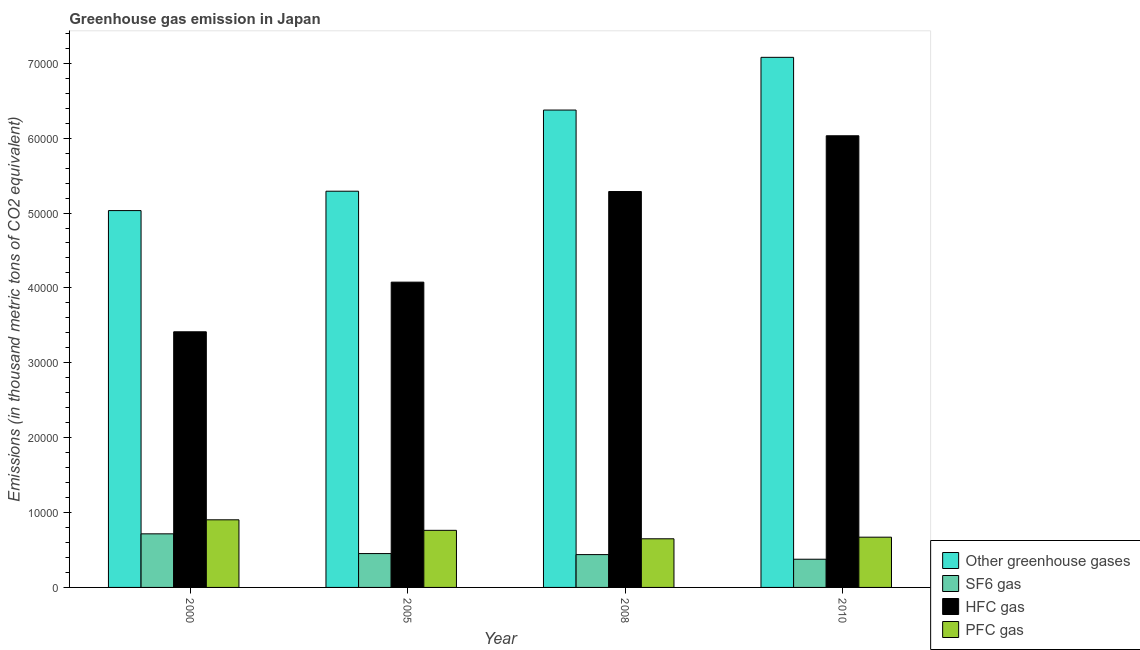Are the number of bars per tick equal to the number of legend labels?
Offer a very short reply. Yes. How many bars are there on the 3rd tick from the right?
Your response must be concise. 4. What is the label of the 4th group of bars from the left?
Ensure brevity in your answer.  2010. What is the emission of hfc gas in 2008?
Give a very brief answer. 5.29e+04. Across all years, what is the maximum emission of greenhouse gases?
Offer a terse response. 7.08e+04. Across all years, what is the minimum emission of pfc gas?
Your answer should be very brief. 6496.1. In which year was the emission of greenhouse gases minimum?
Make the answer very short. 2000. What is the total emission of greenhouse gases in the graph?
Make the answer very short. 2.38e+05. What is the difference between the emission of pfc gas in 2005 and that in 2010?
Offer a terse response. 913.6. What is the difference between the emission of greenhouse gases in 2008 and the emission of hfc gas in 2000?
Provide a short and direct response. 1.34e+04. What is the average emission of greenhouse gases per year?
Give a very brief answer. 5.94e+04. In the year 2010, what is the difference between the emission of sf6 gas and emission of hfc gas?
Offer a very short reply. 0. What is the ratio of the emission of hfc gas in 2000 to that in 2008?
Your answer should be very brief. 0.65. What is the difference between the highest and the second highest emission of hfc gas?
Your answer should be very brief. 7446.1. What is the difference between the highest and the lowest emission of hfc gas?
Ensure brevity in your answer.  2.62e+04. Is it the case that in every year, the sum of the emission of sf6 gas and emission of pfc gas is greater than the sum of emission of greenhouse gases and emission of hfc gas?
Provide a short and direct response. No. What does the 1st bar from the left in 2010 represents?
Your answer should be compact. Other greenhouse gases. What does the 3rd bar from the right in 2010 represents?
Offer a very short reply. SF6 gas. Is it the case that in every year, the sum of the emission of greenhouse gases and emission of sf6 gas is greater than the emission of hfc gas?
Your answer should be compact. Yes. Are all the bars in the graph horizontal?
Provide a succinct answer. No. How many years are there in the graph?
Keep it short and to the point. 4. What is the difference between two consecutive major ticks on the Y-axis?
Your response must be concise. 10000. Does the graph contain any zero values?
Provide a short and direct response. No. Where does the legend appear in the graph?
Provide a short and direct response. Bottom right. How many legend labels are there?
Keep it short and to the point. 4. What is the title of the graph?
Offer a terse response. Greenhouse gas emission in Japan. Does "Rule based governance" appear as one of the legend labels in the graph?
Offer a very short reply. No. What is the label or title of the X-axis?
Give a very brief answer. Year. What is the label or title of the Y-axis?
Offer a terse response. Emissions (in thousand metric tons of CO2 equivalent). What is the Emissions (in thousand metric tons of CO2 equivalent) of Other greenhouse gases in 2000?
Offer a very short reply. 5.03e+04. What is the Emissions (in thousand metric tons of CO2 equivalent) in SF6 gas in 2000?
Ensure brevity in your answer.  7156.6. What is the Emissions (in thousand metric tons of CO2 equivalent) of HFC gas in 2000?
Provide a short and direct response. 3.41e+04. What is the Emissions (in thousand metric tons of CO2 equivalent) of PFC gas in 2000?
Provide a succinct answer. 9029.8. What is the Emissions (in thousand metric tons of CO2 equivalent) in Other greenhouse gases in 2005?
Your response must be concise. 5.29e+04. What is the Emissions (in thousand metric tons of CO2 equivalent) in SF6 gas in 2005?
Provide a succinct answer. 4522.3. What is the Emissions (in thousand metric tons of CO2 equivalent) in HFC gas in 2005?
Provide a short and direct response. 4.08e+04. What is the Emissions (in thousand metric tons of CO2 equivalent) of PFC gas in 2005?
Provide a succinct answer. 7623.6. What is the Emissions (in thousand metric tons of CO2 equivalent) of Other greenhouse gases in 2008?
Make the answer very short. 6.38e+04. What is the Emissions (in thousand metric tons of CO2 equivalent) in SF6 gas in 2008?
Provide a short and direct response. 4382.7. What is the Emissions (in thousand metric tons of CO2 equivalent) of HFC gas in 2008?
Your response must be concise. 5.29e+04. What is the Emissions (in thousand metric tons of CO2 equivalent) of PFC gas in 2008?
Your answer should be compact. 6496.1. What is the Emissions (in thousand metric tons of CO2 equivalent) of Other greenhouse gases in 2010?
Provide a short and direct response. 7.08e+04. What is the Emissions (in thousand metric tons of CO2 equivalent) in SF6 gas in 2010?
Keep it short and to the point. 3765. What is the Emissions (in thousand metric tons of CO2 equivalent) of HFC gas in 2010?
Give a very brief answer. 6.03e+04. What is the Emissions (in thousand metric tons of CO2 equivalent) of PFC gas in 2010?
Your answer should be compact. 6710. Across all years, what is the maximum Emissions (in thousand metric tons of CO2 equivalent) of Other greenhouse gases?
Your answer should be very brief. 7.08e+04. Across all years, what is the maximum Emissions (in thousand metric tons of CO2 equivalent) of SF6 gas?
Your response must be concise. 7156.6. Across all years, what is the maximum Emissions (in thousand metric tons of CO2 equivalent) of HFC gas?
Offer a terse response. 6.03e+04. Across all years, what is the maximum Emissions (in thousand metric tons of CO2 equivalent) of PFC gas?
Make the answer very short. 9029.8. Across all years, what is the minimum Emissions (in thousand metric tons of CO2 equivalent) of Other greenhouse gases?
Offer a very short reply. 5.03e+04. Across all years, what is the minimum Emissions (in thousand metric tons of CO2 equivalent) in SF6 gas?
Your response must be concise. 3765. Across all years, what is the minimum Emissions (in thousand metric tons of CO2 equivalent) in HFC gas?
Offer a very short reply. 3.41e+04. Across all years, what is the minimum Emissions (in thousand metric tons of CO2 equivalent) in PFC gas?
Your answer should be compact. 6496.1. What is the total Emissions (in thousand metric tons of CO2 equivalent) of Other greenhouse gases in the graph?
Your answer should be compact. 2.38e+05. What is the total Emissions (in thousand metric tons of CO2 equivalent) of SF6 gas in the graph?
Keep it short and to the point. 1.98e+04. What is the total Emissions (in thousand metric tons of CO2 equivalent) in HFC gas in the graph?
Give a very brief answer. 1.88e+05. What is the total Emissions (in thousand metric tons of CO2 equivalent) in PFC gas in the graph?
Provide a succinct answer. 2.99e+04. What is the difference between the Emissions (in thousand metric tons of CO2 equivalent) of Other greenhouse gases in 2000 and that in 2005?
Your answer should be compact. -2588.2. What is the difference between the Emissions (in thousand metric tons of CO2 equivalent) in SF6 gas in 2000 and that in 2005?
Offer a terse response. 2634.3. What is the difference between the Emissions (in thousand metric tons of CO2 equivalent) of HFC gas in 2000 and that in 2005?
Provide a short and direct response. -6628.7. What is the difference between the Emissions (in thousand metric tons of CO2 equivalent) of PFC gas in 2000 and that in 2005?
Your response must be concise. 1406.2. What is the difference between the Emissions (in thousand metric tons of CO2 equivalent) in Other greenhouse gases in 2000 and that in 2008?
Offer a terse response. -1.34e+04. What is the difference between the Emissions (in thousand metric tons of CO2 equivalent) in SF6 gas in 2000 and that in 2008?
Offer a terse response. 2773.9. What is the difference between the Emissions (in thousand metric tons of CO2 equivalent) in HFC gas in 2000 and that in 2008?
Offer a terse response. -1.87e+04. What is the difference between the Emissions (in thousand metric tons of CO2 equivalent) of PFC gas in 2000 and that in 2008?
Your answer should be very brief. 2533.7. What is the difference between the Emissions (in thousand metric tons of CO2 equivalent) in Other greenhouse gases in 2000 and that in 2010?
Offer a very short reply. -2.05e+04. What is the difference between the Emissions (in thousand metric tons of CO2 equivalent) of SF6 gas in 2000 and that in 2010?
Offer a terse response. 3391.6. What is the difference between the Emissions (in thousand metric tons of CO2 equivalent) in HFC gas in 2000 and that in 2010?
Give a very brief answer. -2.62e+04. What is the difference between the Emissions (in thousand metric tons of CO2 equivalent) in PFC gas in 2000 and that in 2010?
Make the answer very short. 2319.8. What is the difference between the Emissions (in thousand metric tons of CO2 equivalent) of Other greenhouse gases in 2005 and that in 2008?
Provide a short and direct response. -1.08e+04. What is the difference between the Emissions (in thousand metric tons of CO2 equivalent) of SF6 gas in 2005 and that in 2008?
Offer a terse response. 139.6. What is the difference between the Emissions (in thousand metric tons of CO2 equivalent) of HFC gas in 2005 and that in 2008?
Provide a short and direct response. -1.21e+04. What is the difference between the Emissions (in thousand metric tons of CO2 equivalent) in PFC gas in 2005 and that in 2008?
Offer a terse response. 1127.5. What is the difference between the Emissions (in thousand metric tons of CO2 equivalent) in Other greenhouse gases in 2005 and that in 2010?
Your response must be concise. -1.79e+04. What is the difference between the Emissions (in thousand metric tons of CO2 equivalent) in SF6 gas in 2005 and that in 2010?
Provide a short and direct response. 757.3. What is the difference between the Emissions (in thousand metric tons of CO2 equivalent) of HFC gas in 2005 and that in 2010?
Provide a succinct answer. -1.95e+04. What is the difference between the Emissions (in thousand metric tons of CO2 equivalent) in PFC gas in 2005 and that in 2010?
Make the answer very short. 913.6. What is the difference between the Emissions (in thousand metric tons of CO2 equivalent) in Other greenhouse gases in 2008 and that in 2010?
Offer a very short reply. -7042.3. What is the difference between the Emissions (in thousand metric tons of CO2 equivalent) of SF6 gas in 2008 and that in 2010?
Offer a terse response. 617.7. What is the difference between the Emissions (in thousand metric tons of CO2 equivalent) of HFC gas in 2008 and that in 2010?
Your response must be concise. -7446.1. What is the difference between the Emissions (in thousand metric tons of CO2 equivalent) in PFC gas in 2008 and that in 2010?
Offer a very short reply. -213.9. What is the difference between the Emissions (in thousand metric tons of CO2 equivalent) in Other greenhouse gases in 2000 and the Emissions (in thousand metric tons of CO2 equivalent) in SF6 gas in 2005?
Your answer should be compact. 4.58e+04. What is the difference between the Emissions (in thousand metric tons of CO2 equivalent) in Other greenhouse gases in 2000 and the Emissions (in thousand metric tons of CO2 equivalent) in HFC gas in 2005?
Your answer should be compact. 9557.7. What is the difference between the Emissions (in thousand metric tons of CO2 equivalent) of Other greenhouse gases in 2000 and the Emissions (in thousand metric tons of CO2 equivalent) of PFC gas in 2005?
Give a very brief answer. 4.27e+04. What is the difference between the Emissions (in thousand metric tons of CO2 equivalent) in SF6 gas in 2000 and the Emissions (in thousand metric tons of CO2 equivalent) in HFC gas in 2005?
Make the answer very short. -3.36e+04. What is the difference between the Emissions (in thousand metric tons of CO2 equivalent) in SF6 gas in 2000 and the Emissions (in thousand metric tons of CO2 equivalent) in PFC gas in 2005?
Your response must be concise. -467. What is the difference between the Emissions (in thousand metric tons of CO2 equivalent) of HFC gas in 2000 and the Emissions (in thousand metric tons of CO2 equivalent) of PFC gas in 2005?
Your response must be concise. 2.65e+04. What is the difference between the Emissions (in thousand metric tons of CO2 equivalent) in Other greenhouse gases in 2000 and the Emissions (in thousand metric tons of CO2 equivalent) in SF6 gas in 2008?
Offer a very short reply. 4.59e+04. What is the difference between the Emissions (in thousand metric tons of CO2 equivalent) of Other greenhouse gases in 2000 and the Emissions (in thousand metric tons of CO2 equivalent) of HFC gas in 2008?
Offer a very short reply. -2545.7. What is the difference between the Emissions (in thousand metric tons of CO2 equivalent) in Other greenhouse gases in 2000 and the Emissions (in thousand metric tons of CO2 equivalent) in PFC gas in 2008?
Offer a very short reply. 4.38e+04. What is the difference between the Emissions (in thousand metric tons of CO2 equivalent) in SF6 gas in 2000 and the Emissions (in thousand metric tons of CO2 equivalent) in HFC gas in 2008?
Your answer should be compact. -4.57e+04. What is the difference between the Emissions (in thousand metric tons of CO2 equivalent) in SF6 gas in 2000 and the Emissions (in thousand metric tons of CO2 equivalent) in PFC gas in 2008?
Keep it short and to the point. 660.5. What is the difference between the Emissions (in thousand metric tons of CO2 equivalent) of HFC gas in 2000 and the Emissions (in thousand metric tons of CO2 equivalent) of PFC gas in 2008?
Your answer should be compact. 2.76e+04. What is the difference between the Emissions (in thousand metric tons of CO2 equivalent) in Other greenhouse gases in 2000 and the Emissions (in thousand metric tons of CO2 equivalent) in SF6 gas in 2010?
Your answer should be compact. 4.66e+04. What is the difference between the Emissions (in thousand metric tons of CO2 equivalent) of Other greenhouse gases in 2000 and the Emissions (in thousand metric tons of CO2 equivalent) of HFC gas in 2010?
Keep it short and to the point. -9991.8. What is the difference between the Emissions (in thousand metric tons of CO2 equivalent) of Other greenhouse gases in 2000 and the Emissions (in thousand metric tons of CO2 equivalent) of PFC gas in 2010?
Ensure brevity in your answer.  4.36e+04. What is the difference between the Emissions (in thousand metric tons of CO2 equivalent) of SF6 gas in 2000 and the Emissions (in thousand metric tons of CO2 equivalent) of HFC gas in 2010?
Your answer should be compact. -5.32e+04. What is the difference between the Emissions (in thousand metric tons of CO2 equivalent) in SF6 gas in 2000 and the Emissions (in thousand metric tons of CO2 equivalent) in PFC gas in 2010?
Offer a very short reply. 446.6. What is the difference between the Emissions (in thousand metric tons of CO2 equivalent) in HFC gas in 2000 and the Emissions (in thousand metric tons of CO2 equivalent) in PFC gas in 2010?
Ensure brevity in your answer.  2.74e+04. What is the difference between the Emissions (in thousand metric tons of CO2 equivalent) in Other greenhouse gases in 2005 and the Emissions (in thousand metric tons of CO2 equivalent) in SF6 gas in 2008?
Offer a terse response. 4.85e+04. What is the difference between the Emissions (in thousand metric tons of CO2 equivalent) of Other greenhouse gases in 2005 and the Emissions (in thousand metric tons of CO2 equivalent) of HFC gas in 2008?
Give a very brief answer. 42.5. What is the difference between the Emissions (in thousand metric tons of CO2 equivalent) in Other greenhouse gases in 2005 and the Emissions (in thousand metric tons of CO2 equivalent) in PFC gas in 2008?
Make the answer very short. 4.64e+04. What is the difference between the Emissions (in thousand metric tons of CO2 equivalent) of SF6 gas in 2005 and the Emissions (in thousand metric tons of CO2 equivalent) of HFC gas in 2008?
Give a very brief answer. -4.83e+04. What is the difference between the Emissions (in thousand metric tons of CO2 equivalent) of SF6 gas in 2005 and the Emissions (in thousand metric tons of CO2 equivalent) of PFC gas in 2008?
Offer a terse response. -1973.8. What is the difference between the Emissions (in thousand metric tons of CO2 equivalent) of HFC gas in 2005 and the Emissions (in thousand metric tons of CO2 equivalent) of PFC gas in 2008?
Make the answer very short. 3.43e+04. What is the difference between the Emissions (in thousand metric tons of CO2 equivalent) in Other greenhouse gases in 2005 and the Emissions (in thousand metric tons of CO2 equivalent) in SF6 gas in 2010?
Make the answer very short. 4.91e+04. What is the difference between the Emissions (in thousand metric tons of CO2 equivalent) in Other greenhouse gases in 2005 and the Emissions (in thousand metric tons of CO2 equivalent) in HFC gas in 2010?
Your response must be concise. -7403.6. What is the difference between the Emissions (in thousand metric tons of CO2 equivalent) in Other greenhouse gases in 2005 and the Emissions (in thousand metric tons of CO2 equivalent) in PFC gas in 2010?
Ensure brevity in your answer.  4.62e+04. What is the difference between the Emissions (in thousand metric tons of CO2 equivalent) of SF6 gas in 2005 and the Emissions (in thousand metric tons of CO2 equivalent) of HFC gas in 2010?
Provide a short and direct response. -5.58e+04. What is the difference between the Emissions (in thousand metric tons of CO2 equivalent) of SF6 gas in 2005 and the Emissions (in thousand metric tons of CO2 equivalent) of PFC gas in 2010?
Make the answer very short. -2187.7. What is the difference between the Emissions (in thousand metric tons of CO2 equivalent) in HFC gas in 2005 and the Emissions (in thousand metric tons of CO2 equivalent) in PFC gas in 2010?
Ensure brevity in your answer.  3.41e+04. What is the difference between the Emissions (in thousand metric tons of CO2 equivalent) of Other greenhouse gases in 2008 and the Emissions (in thousand metric tons of CO2 equivalent) of SF6 gas in 2010?
Offer a terse response. 6.00e+04. What is the difference between the Emissions (in thousand metric tons of CO2 equivalent) in Other greenhouse gases in 2008 and the Emissions (in thousand metric tons of CO2 equivalent) in HFC gas in 2010?
Provide a short and direct response. 3432.7. What is the difference between the Emissions (in thousand metric tons of CO2 equivalent) in Other greenhouse gases in 2008 and the Emissions (in thousand metric tons of CO2 equivalent) in PFC gas in 2010?
Your answer should be very brief. 5.70e+04. What is the difference between the Emissions (in thousand metric tons of CO2 equivalent) in SF6 gas in 2008 and the Emissions (in thousand metric tons of CO2 equivalent) in HFC gas in 2010?
Offer a very short reply. -5.59e+04. What is the difference between the Emissions (in thousand metric tons of CO2 equivalent) in SF6 gas in 2008 and the Emissions (in thousand metric tons of CO2 equivalent) in PFC gas in 2010?
Offer a terse response. -2327.3. What is the difference between the Emissions (in thousand metric tons of CO2 equivalent) of HFC gas in 2008 and the Emissions (in thousand metric tons of CO2 equivalent) of PFC gas in 2010?
Provide a short and direct response. 4.62e+04. What is the average Emissions (in thousand metric tons of CO2 equivalent) of Other greenhouse gases per year?
Offer a very short reply. 5.94e+04. What is the average Emissions (in thousand metric tons of CO2 equivalent) of SF6 gas per year?
Your answer should be compact. 4956.65. What is the average Emissions (in thousand metric tons of CO2 equivalent) of HFC gas per year?
Make the answer very short. 4.70e+04. What is the average Emissions (in thousand metric tons of CO2 equivalent) in PFC gas per year?
Your response must be concise. 7464.88. In the year 2000, what is the difference between the Emissions (in thousand metric tons of CO2 equivalent) in Other greenhouse gases and Emissions (in thousand metric tons of CO2 equivalent) in SF6 gas?
Make the answer very short. 4.32e+04. In the year 2000, what is the difference between the Emissions (in thousand metric tons of CO2 equivalent) of Other greenhouse gases and Emissions (in thousand metric tons of CO2 equivalent) of HFC gas?
Keep it short and to the point. 1.62e+04. In the year 2000, what is the difference between the Emissions (in thousand metric tons of CO2 equivalent) of Other greenhouse gases and Emissions (in thousand metric tons of CO2 equivalent) of PFC gas?
Your answer should be very brief. 4.13e+04. In the year 2000, what is the difference between the Emissions (in thousand metric tons of CO2 equivalent) in SF6 gas and Emissions (in thousand metric tons of CO2 equivalent) in HFC gas?
Your answer should be compact. -2.70e+04. In the year 2000, what is the difference between the Emissions (in thousand metric tons of CO2 equivalent) in SF6 gas and Emissions (in thousand metric tons of CO2 equivalent) in PFC gas?
Offer a terse response. -1873.2. In the year 2000, what is the difference between the Emissions (in thousand metric tons of CO2 equivalent) of HFC gas and Emissions (in thousand metric tons of CO2 equivalent) of PFC gas?
Ensure brevity in your answer.  2.51e+04. In the year 2005, what is the difference between the Emissions (in thousand metric tons of CO2 equivalent) in Other greenhouse gases and Emissions (in thousand metric tons of CO2 equivalent) in SF6 gas?
Give a very brief answer. 4.84e+04. In the year 2005, what is the difference between the Emissions (in thousand metric tons of CO2 equivalent) in Other greenhouse gases and Emissions (in thousand metric tons of CO2 equivalent) in HFC gas?
Provide a short and direct response. 1.21e+04. In the year 2005, what is the difference between the Emissions (in thousand metric tons of CO2 equivalent) of Other greenhouse gases and Emissions (in thousand metric tons of CO2 equivalent) of PFC gas?
Provide a succinct answer. 4.53e+04. In the year 2005, what is the difference between the Emissions (in thousand metric tons of CO2 equivalent) of SF6 gas and Emissions (in thousand metric tons of CO2 equivalent) of HFC gas?
Give a very brief answer. -3.62e+04. In the year 2005, what is the difference between the Emissions (in thousand metric tons of CO2 equivalent) in SF6 gas and Emissions (in thousand metric tons of CO2 equivalent) in PFC gas?
Provide a succinct answer. -3101.3. In the year 2005, what is the difference between the Emissions (in thousand metric tons of CO2 equivalent) in HFC gas and Emissions (in thousand metric tons of CO2 equivalent) in PFC gas?
Give a very brief answer. 3.31e+04. In the year 2008, what is the difference between the Emissions (in thousand metric tons of CO2 equivalent) in Other greenhouse gases and Emissions (in thousand metric tons of CO2 equivalent) in SF6 gas?
Your answer should be very brief. 5.94e+04. In the year 2008, what is the difference between the Emissions (in thousand metric tons of CO2 equivalent) in Other greenhouse gases and Emissions (in thousand metric tons of CO2 equivalent) in HFC gas?
Provide a short and direct response. 1.09e+04. In the year 2008, what is the difference between the Emissions (in thousand metric tons of CO2 equivalent) of Other greenhouse gases and Emissions (in thousand metric tons of CO2 equivalent) of PFC gas?
Make the answer very short. 5.73e+04. In the year 2008, what is the difference between the Emissions (in thousand metric tons of CO2 equivalent) in SF6 gas and Emissions (in thousand metric tons of CO2 equivalent) in HFC gas?
Offer a very short reply. -4.85e+04. In the year 2008, what is the difference between the Emissions (in thousand metric tons of CO2 equivalent) of SF6 gas and Emissions (in thousand metric tons of CO2 equivalent) of PFC gas?
Your response must be concise. -2113.4. In the year 2008, what is the difference between the Emissions (in thousand metric tons of CO2 equivalent) in HFC gas and Emissions (in thousand metric tons of CO2 equivalent) in PFC gas?
Make the answer very short. 4.64e+04. In the year 2010, what is the difference between the Emissions (in thousand metric tons of CO2 equivalent) in Other greenhouse gases and Emissions (in thousand metric tons of CO2 equivalent) in SF6 gas?
Your answer should be very brief. 6.70e+04. In the year 2010, what is the difference between the Emissions (in thousand metric tons of CO2 equivalent) of Other greenhouse gases and Emissions (in thousand metric tons of CO2 equivalent) of HFC gas?
Your answer should be compact. 1.05e+04. In the year 2010, what is the difference between the Emissions (in thousand metric tons of CO2 equivalent) in Other greenhouse gases and Emissions (in thousand metric tons of CO2 equivalent) in PFC gas?
Provide a succinct answer. 6.41e+04. In the year 2010, what is the difference between the Emissions (in thousand metric tons of CO2 equivalent) in SF6 gas and Emissions (in thousand metric tons of CO2 equivalent) in HFC gas?
Your answer should be very brief. -5.66e+04. In the year 2010, what is the difference between the Emissions (in thousand metric tons of CO2 equivalent) of SF6 gas and Emissions (in thousand metric tons of CO2 equivalent) of PFC gas?
Provide a short and direct response. -2945. In the year 2010, what is the difference between the Emissions (in thousand metric tons of CO2 equivalent) of HFC gas and Emissions (in thousand metric tons of CO2 equivalent) of PFC gas?
Your answer should be very brief. 5.36e+04. What is the ratio of the Emissions (in thousand metric tons of CO2 equivalent) of Other greenhouse gases in 2000 to that in 2005?
Your response must be concise. 0.95. What is the ratio of the Emissions (in thousand metric tons of CO2 equivalent) in SF6 gas in 2000 to that in 2005?
Your answer should be very brief. 1.58. What is the ratio of the Emissions (in thousand metric tons of CO2 equivalent) in HFC gas in 2000 to that in 2005?
Your answer should be compact. 0.84. What is the ratio of the Emissions (in thousand metric tons of CO2 equivalent) in PFC gas in 2000 to that in 2005?
Provide a succinct answer. 1.18. What is the ratio of the Emissions (in thousand metric tons of CO2 equivalent) of Other greenhouse gases in 2000 to that in 2008?
Give a very brief answer. 0.79. What is the ratio of the Emissions (in thousand metric tons of CO2 equivalent) in SF6 gas in 2000 to that in 2008?
Provide a short and direct response. 1.63. What is the ratio of the Emissions (in thousand metric tons of CO2 equivalent) in HFC gas in 2000 to that in 2008?
Your answer should be compact. 0.65. What is the ratio of the Emissions (in thousand metric tons of CO2 equivalent) of PFC gas in 2000 to that in 2008?
Your response must be concise. 1.39. What is the ratio of the Emissions (in thousand metric tons of CO2 equivalent) in Other greenhouse gases in 2000 to that in 2010?
Keep it short and to the point. 0.71. What is the ratio of the Emissions (in thousand metric tons of CO2 equivalent) of SF6 gas in 2000 to that in 2010?
Provide a short and direct response. 1.9. What is the ratio of the Emissions (in thousand metric tons of CO2 equivalent) of HFC gas in 2000 to that in 2010?
Keep it short and to the point. 0.57. What is the ratio of the Emissions (in thousand metric tons of CO2 equivalent) of PFC gas in 2000 to that in 2010?
Offer a terse response. 1.35. What is the ratio of the Emissions (in thousand metric tons of CO2 equivalent) in Other greenhouse gases in 2005 to that in 2008?
Your answer should be very brief. 0.83. What is the ratio of the Emissions (in thousand metric tons of CO2 equivalent) in SF6 gas in 2005 to that in 2008?
Ensure brevity in your answer.  1.03. What is the ratio of the Emissions (in thousand metric tons of CO2 equivalent) in HFC gas in 2005 to that in 2008?
Give a very brief answer. 0.77. What is the ratio of the Emissions (in thousand metric tons of CO2 equivalent) in PFC gas in 2005 to that in 2008?
Ensure brevity in your answer.  1.17. What is the ratio of the Emissions (in thousand metric tons of CO2 equivalent) in Other greenhouse gases in 2005 to that in 2010?
Provide a short and direct response. 0.75. What is the ratio of the Emissions (in thousand metric tons of CO2 equivalent) of SF6 gas in 2005 to that in 2010?
Keep it short and to the point. 1.2. What is the ratio of the Emissions (in thousand metric tons of CO2 equivalent) of HFC gas in 2005 to that in 2010?
Your response must be concise. 0.68. What is the ratio of the Emissions (in thousand metric tons of CO2 equivalent) in PFC gas in 2005 to that in 2010?
Provide a succinct answer. 1.14. What is the ratio of the Emissions (in thousand metric tons of CO2 equivalent) of Other greenhouse gases in 2008 to that in 2010?
Make the answer very short. 0.9. What is the ratio of the Emissions (in thousand metric tons of CO2 equivalent) of SF6 gas in 2008 to that in 2010?
Offer a very short reply. 1.16. What is the ratio of the Emissions (in thousand metric tons of CO2 equivalent) of HFC gas in 2008 to that in 2010?
Offer a terse response. 0.88. What is the ratio of the Emissions (in thousand metric tons of CO2 equivalent) of PFC gas in 2008 to that in 2010?
Your response must be concise. 0.97. What is the difference between the highest and the second highest Emissions (in thousand metric tons of CO2 equivalent) in Other greenhouse gases?
Your answer should be compact. 7042.3. What is the difference between the highest and the second highest Emissions (in thousand metric tons of CO2 equivalent) of SF6 gas?
Your answer should be very brief. 2634.3. What is the difference between the highest and the second highest Emissions (in thousand metric tons of CO2 equivalent) in HFC gas?
Provide a short and direct response. 7446.1. What is the difference between the highest and the second highest Emissions (in thousand metric tons of CO2 equivalent) in PFC gas?
Provide a short and direct response. 1406.2. What is the difference between the highest and the lowest Emissions (in thousand metric tons of CO2 equivalent) of Other greenhouse gases?
Give a very brief answer. 2.05e+04. What is the difference between the highest and the lowest Emissions (in thousand metric tons of CO2 equivalent) in SF6 gas?
Your answer should be very brief. 3391.6. What is the difference between the highest and the lowest Emissions (in thousand metric tons of CO2 equivalent) in HFC gas?
Your answer should be very brief. 2.62e+04. What is the difference between the highest and the lowest Emissions (in thousand metric tons of CO2 equivalent) of PFC gas?
Provide a succinct answer. 2533.7. 